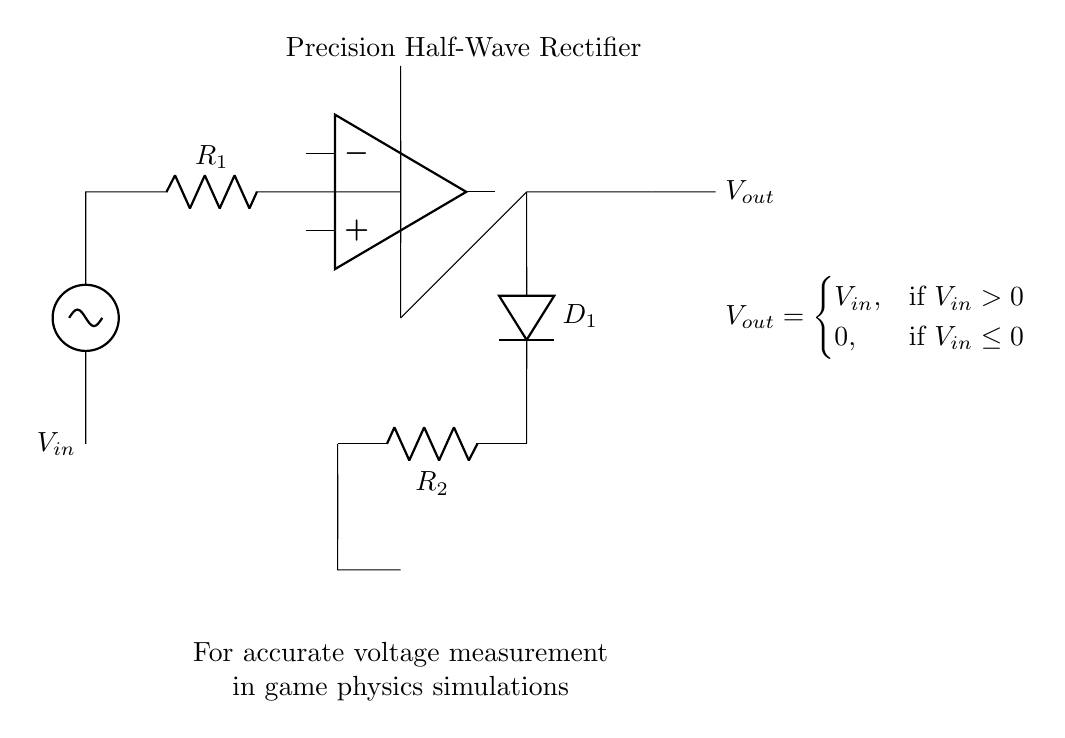What is the input voltage of the circuit? The input voltage is denoted as V_in, which is the voltage source connected at the left side of the circuit diagram.
Answer: V_in What component is used for rectification? The component responsible for rectification in this circuit is a diode, specifically labeled as D_1 in the diagram.
Answer: D_1 What is the function of the op-amp in this circuit? The operational amplifier (op-amp) amplifies the input signal to ensure that the output accurately follows the input when it is positive, effectively allowing for precision rectification.
Answer: Amplifier What happens to V_out when V_in is negative? According to the equation provided in the circuit, if the input voltage V_in is less than or equal to zero, the output voltage V_out is zero because the diode will not conduct.
Answer: 0 How many resistors are present in the circuit? There are two resistors in the circuit: R_1 and R_2, which are labeled in the diagram.
Answer: 2 What is the purpose of R_1 in the circuit? R_1 limits the current flowing into the op-amp and helps set the gain, which is crucial for the correct operation of the precision rectifier function.
Answer: Current limiter What condition must be met for V_out to equal V_in? For the output voltage V_out to equal the input voltage V_in, V_in must be greater than zero, as indicated in the equation shown in the circuit.
Answer: V_in > 0 